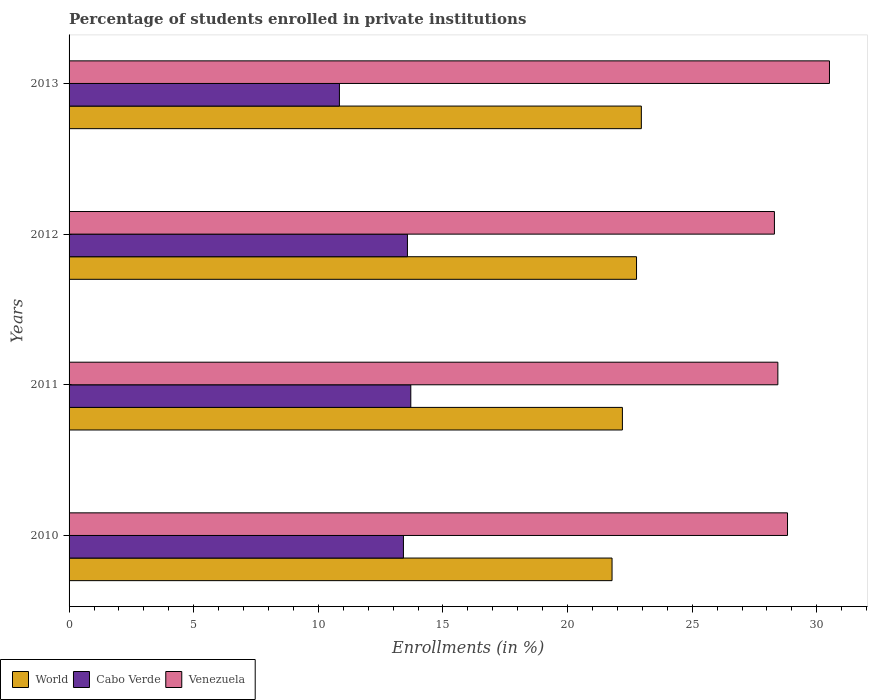Are the number of bars per tick equal to the number of legend labels?
Your response must be concise. Yes. How many bars are there on the 1st tick from the top?
Your answer should be very brief. 3. In how many cases, is the number of bars for a given year not equal to the number of legend labels?
Ensure brevity in your answer.  0. What is the percentage of trained teachers in Venezuela in 2010?
Make the answer very short. 28.82. Across all years, what is the maximum percentage of trained teachers in Venezuela?
Your answer should be compact. 30.51. Across all years, what is the minimum percentage of trained teachers in World?
Your answer should be compact. 21.78. In which year was the percentage of trained teachers in Venezuela maximum?
Offer a terse response. 2013. In which year was the percentage of trained teachers in World minimum?
Provide a short and direct response. 2010. What is the total percentage of trained teachers in World in the graph?
Keep it short and to the point. 89.71. What is the difference between the percentage of trained teachers in Venezuela in 2012 and that in 2013?
Offer a terse response. -2.21. What is the difference between the percentage of trained teachers in Cabo Verde in 2010 and the percentage of trained teachers in Venezuela in 2013?
Offer a very short reply. -17.09. What is the average percentage of trained teachers in Venezuela per year?
Provide a succinct answer. 29.02. In the year 2013, what is the difference between the percentage of trained teachers in World and percentage of trained teachers in Venezuela?
Your answer should be compact. -7.55. What is the ratio of the percentage of trained teachers in World in 2012 to that in 2013?
Make the answer very short. 0.99. What is the difference between the highest and the second highest percentage of trained teachers in Venezuela?
Your answer should be compact. 1.68. What is the difference between the highest and the lowest percentage of trained teachers in Cabo Verde?
Provide a succinct answer. 2.86. In how many years, is the percentage of trained teachers in Venezuela greater than the average percentage of trained teachers in Venezuela taken over all years?
Provide a succinct answer. 1. What does the 3rd bar from the top in 2013 represents?
Your answer should be very brief. World. What does the 3rd bar from the bottom in 2011 represents?
Your answer should be compact. Venezuela. Is it the case that in every year, the sum of the percentage of trained teachers in World and percentage of trained teachers in Venezuela is greater than the percentage of trained teachers in Cabo Verde?
Give a very brief answer. Yes. How many bars are there?
Offer a terse response. 12. Are all the bars in the graph horizontal?
Ensure brevity in your answer.  Yes. Does the graph contain grids?
Offer a very short reply. No. Where does the legend appear in the graph?
Keep it short and to the point. Bottom left. How many legend labels are there?
Make the answer very short. 3. What is the title of the graph?
Provide a short and direct response. Percentage of students enrolled in private institutions. What is the label or title of the X-axis?
Give a very brief answer. Enrollments (in %). What is the Enrollments (in %) of World in 2010?
Your answer should be compact. 21.78. What is the Enrollments (in %) in Cabo Verde in 2010?
Your response must be concise. 13.42. What is the Enrollments (in %) of Venezuela in 2010?
Provide a succinct answer. 28.82. What is the Enrollments (in %) of World in 2011?
Provide a short and direct response. 22.2. What is the Enrollments (in %) of Cabo Verde in 2011?
Your answer should be very brief. 13.71. What is the Enrollments (in %) of Venezuela in 2011?
Your answer should be compact. 28.44. What is the Enrollments (in %) in World in 2012?
Your answer should be very brief. 22.77. What is the Enrollments (in %) of Cabo Verde in 2012?
Make the answer very short. 13.58. What is the Enrollments (in %) of Venezuela in 2012?
Offer a terse response. 28.3. What is the Enrollments (in %) of World in 2013?
Provide a succinct answer. 22.96. What is the Enrollments (in %) of Cabo Verde in 2013?
Your answer should be compact. 10.85. What is the Enrollments (in %) of Venezuela in 2013?
Provide a succinct answer. 30.51. Across all years, what is the maximum Enrollments (in %) in World?
Keep it short and to the point. 22.96. Across all years, what is the maximum Enrollments (in %) of Cabo Verde?
Your answer should be compact. 13.71. Across all years, what is the maximum Enrollments (in %) in Venezuela?
Ensure brevity in your answer.  30.51. Across all years, what is the minimum Enrollments (in %) in World?
Give a very brief answer. 21.78. Across all years, what is the minimum Enrollments (in %) in Cabo Verde?
Offer a very short reply. 10.85. Across all years, what is the minimum Enrollments (in %) in Venezuela?
Make the answer very short. 28.3. What is the total Enrollments (in %) in World in the graph?
Keep it short and to the point. 89.71. What is the total Enrollments (in %) in Cabo Verde in the graph?
Provide a short and direct response. 51.55. What is the total Enrollments (in %) in Venezuela in the graph?
Your answer should be very brief. 116.07. What is the difference between the Enrollments (in %) in World in 2010 and that in 2011?
Make the answer very short. -0.42. What is the difference between the Enrollments (in %) of Cabo Verde in 2010 and that in 2011?
Offer a very short reply. -0.3. What is the difference between the Enrollments (in %) of Venezuela in 2010 and that in 2011?
Give a very brief answer. 0.39. What is the difference between the Enrollments (in %) of World in 2010 and that in 2012?
Provide a succinct answer. -0.98. What is the difference between the Enrollments (in %) in Cabo Verde in 2010 and that in 2012?
Your response must be concise. -0.16. What is the difference between the Enrollments (in %) in Venezuela in 2010 and that in 2012?
Your answer should be compact. 0.53. What is the difference between the Enrollments (in %) of World in 2010 and that in 2013?
Offer a very short reply. -1.18. What is the difference between the Enrollments (in %) in Cabo Verde in 2010 and that in 2013?
Give a very brief answer. 2.57. What is the difference between the Enrollments (in %) of Venezuela in 2010 and that in 2013?
Your answer should be compact. -1.68. What is the difference between the Enrollments (in %) in World in 2011 and that in 2012?
Your response must be concise. -0.57. What is the difference between the Enrollments (in %) of Cabo Verde in 2011 and that in 2012?
Give a very brief answer. 0.13. What is the difference between the Enrollments (in %) of Venezuela in 2011 and that in 2012?
Keep it short and to the point. 0.14. What is the difference between the Enrollments (in %) in World in 2011 and that in 2013?
Give a very brief answer. -0.76. What is the difference between the Enrollments (in %) of Cabo Verde in 2011 and that in 2013?
Give a very brief answer. 2.86. What is the difference between the Enrollments (in %) of Venezuela in 2011 and that in 2013?
Make the answer very short. -2.07. What is the difference between the Enrollments (in %) of World in 2012 and that in 2013?
Provide a short and direct response. -0.19. What is the difference between the Enrollments (in %) in Cabo Verde in 2012 and that in 2013?
Offer a very short reply. 2.73. What is the difference between the Enrollments (in %) of Venezuela in 2012 and that in 2013?
Your answer should be compact. -2.21. What is the difference between the Enrollments (in %) in World in 2010 and the Enrollments (in %) in Cabo Verde in 2011?
Ensure brevity in your answer.  8.07. What is the difference between the Enrollments (in %) of World in 2010 and the Enrollments (in %) of Venezuela in 2011?
Your answer should be very brief. -6.65. What is the difference between the Enrollments (in %) in Cabo Verde in 2010 and the Enrollments (in %) in Venezuela in 2011?
Ensure brevity in your answer.  -15.02. What is the difference between the Enrollments (in %) in World in 2010 and the Enrollments (in %) in Cabo Verde in 2012?
Your answer should be compact. 8.21. What is the difference between the Enrollments (in %) of World in 2010 and the Enrollments (in %) of Venezuela in 2012?
Provide a short and direct response. -6.51. What is the difference between the Enrollments (in %) of Cabo Verde in 2010 and the Enrollments (in %) of Venezuela in 2012?
Give a very brief answer. -14.88. What is the difference between the Enrollments (in %) of World in 2010 and the Enrollments (in %) of Cabo Verde in 2013?
Offer a terse response. 10.94. What is the difference between the Enrollments (in %) of World in 2010 and the Enrollments (in %) of Venezuela in 2013?
Your answer should be very brief. -8.72. What is the difference between the Enrollments (in %) in Cabo Verde in 2010 and the Enrollments (in %) in Venezuela in 2013?
Keep it short and to the point. -17.09. What is the difference between the Enrollments (in %) in World in 2011 and the Enrollments (in %) in Cabo Verde in 2012?
Offer a very short reply. 8.62. What is the difference between the Enrollments (in %) of World in 2011 and the Enrollments (in %) of Venezuela in 2012?
Offer a terse response. -6.1. What is the difference between the Enrollments (in %) in Cabo Verde in 2011 and the Enrollments (in %) in Venezuela in 2012?
Your answer should be compact. -14.59. What is the difference between the Enrollments (in %) of World in 2011 and the Enrollments (in %) of Cabo Verde in 2013?
Provide a succinct answer. 11.35. What is the difference between the Enrollments (in %) of World in 2011 and the Enrollments (in %) of Venezuela in 2013?
Keep it short and to the point. -8.31. What is the difference between the Enrollments (in %) of Cabo Verde in 2011 and the Enrollments (in %) of Venezuela in 2013?
Offer a very short reply. -16.8. What is the difference between the Enrollments (in %) in World in 2012 and the Enrollments (in %) in Cabo Verde in 2013?
Provide a short and direct response. 11.92. What is the difference between the Enrollments (in %) in World in 2012 and the Enrollments (in %) in Venezuela in 2013?
Offer a terse response. -7.74. What is the difference between the Enrollments (in %) in Cabo Verde in 2012 and the Enrollments (in %) in Venezuela in 2013?
Offer a terse response. -16.93. What is the average Enrollments (in %) in World per year?
Your answer should be compact. 22.43. What is the average Enrollments (in %) in Cabo Verde per year?
Offer a very short reply. 12.89. What is the average Enrollments (in %) in Venezuela per year?
Your answer should be very brief. 29.02. In the year 2010, what is the difference between the Enrollments (in %) of World and Enrollments (in %) of Cabo Verde?
Give a very brief answer. 8.37. In the year 2010, what is the difference between the Enrollments (in %) of World and Enrollments (in %) of Venezuela?
Provide a short and direct response. -7.04. In the year 2010, what is the difference between the Enrollments (in %) of Cabo Verde and Enrollments (in %) of Venezuela?
Provide a short and direct response. -15.41. In the year 2011, what is the difference between the Enrollments (in %) in World and Enrollments (in %) in Cabo Verde?
Your answer should be very brief. 8.49. In the year 2011, what is the difference between the Enrollments (in %) in World and Enrollments (in %) in Venezuela?
Offer a very short reply. -6.24. In the year 2011, what is the difference between the Enrollments (in %) in Cabo Verde and Enrollments (in %) in Venezuela?
Offer a very short reply. -14.73. In the year 2012, what is the difference between the Enrollments (in %) in World and Enrollments (in %) in Cabo Verde?
Offer a very short reply. 9.19. In the year 2012, what is the difference between the Enrollments (in %) of World and Enrollments (in %) of Venezuela?
Your answer should be compact. -5.53. In the year 2012, what is the difference between the Enrollments (in %) of Cabo Verde and Enrollments (in %) of Venezuela?
Keep it short and to the point. -14.72. In the year 2013, what is the difference between the Enrollments (in %) in World and Enrollments (in %) in Cabo Verde?
Give a very brief answer. 12.11. In the year 2013, what is the difference between the Enrollments (in %) in World and Enrollments (in %) in Venezuela?
Give a very brief answer. -7.55. In the year 2013, what is the difference between the Enrollments (in %) of Cabo Verde and Enrollments (in %) of Venezuela?
Your response must be concise. -19.66. What is the ratio of the Enrollments (in %) in World in 2010 to that in 2011?
Your answer should be very brief. 0.98. What is the ratio of the Enrollments (in %) in Cabo Verde in 2010 to that in 2011?
Offer a terse response. 0.98. What is the ratio of the Enrollments (in %) in Venezuela in 2010 to that in 2011?
Make the answer very short. 1.01. What is the ratio of the Enrollments (in %) of World in 2010 to that in 2012?
Ensure brevity in your answer.  0.96. What is the ratio of the Enrollments (in %) in Venezuela in 2010 to that in 2012?
Make the answer very short. 1.02. What is the ratio of the Enrollments (in %) in World in 2010 to that in 2013?
Keep it short and to the point. 0.95. What is the ratio of the Enrollments (in %) in Cabo Verde in 2010 to that in 2013?
Your answer should be very brief. 1.24. What is the ratio of the Enrollments (in %) of Venezuela in 2010 to that in 2013?
Offer a very short reply. 0.94. What is the ratio of the Enrollments (in %) in World in 2011 to that in 2012?
Offer a very short reply. 0.98. What is the ratio of the Enrollments (in %) of Cabo Verde in 2011 to that in 2012?
Offer a terse response. 1.01. What is the ratio of the Enrollments (in %) in Venezuela in 2011 to that in 2012?
Provide a short and direct response. 1. What is the ratio of the Enrollments (in %) in World in 2011 to that in 2013?
Your answer should be compact. 0.97. What is the ratio of the Enrollments (in %) in Cabo Verde in 2011 to that in 2013?
Keep it short and to the point. 1.26. What is the ratio of the Enrollments (in %) of Venezuela in 2011 to that in 2013?
Make the answer very short. 0.93. What is the ratio of the Enrollments (in %) of Cabo Verde in 2012 to that in 2013?
Give a very brief answer. 1.25. What is the ratio of the Enrollments (in %) of Venezuela in 2012 to that in 2013?
Make the answer very short. 0.93. What is the difference between the highest and the second highest Enrollments (in %) in World?
Ensure brevity in your answer.  0.19. What is the difference between the highest and the second highest Enrollments (in %) of Cabo Verde?
Ensure brevity in your answer.  0.13. What is the difference between the highest and the second highest Enrollments (in %) in Venezuela?
Offer a terse response. 1.68. What is the difference between the highest and the lowest Enrollments (in %) in World?
Offer a very short reply. 1.18. What is the difference between the highest and the lowest Enrollments (in %) of Cabo Verde?
Provide a succinct answer. 2.86. What is the difference between the highest and the lowest Enrollments (in %) of Venezuela?
Give a very brief answer. 2.21. 